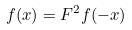<formula> <loc_0><loc_0><loc_500><loc_500>f ( x ) = F ^ { 2 } f ( - x )</formula> 